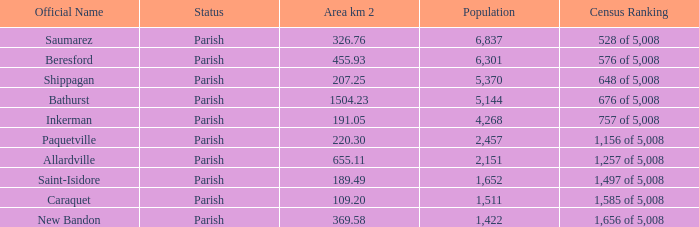What is the extent of the allardville parish with a population below 2,151? None. 